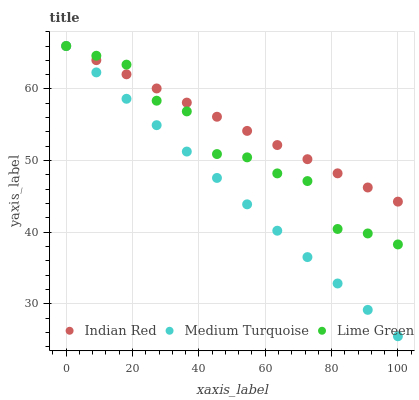Does Medium Turquoise have the minimum area under the curve?
Answer yes or no. Yes. Does Indian Red have the maximum area under the curve?
Answer yes or no. Yes. Does Indian Red have the minimum area under the curve?
Answer yes or no. No. Does Medium Turquoise have the maximum area under the curve?
Answer yes or no. No. Is Indian Red the smoothest?
Answer yes or no. Yes. Is Lime Green the roughest?
Answer yes or no. Yes. Is Medium Turquoise the smoothest?
Answer yes or no. No. Is Medium Turquoise the roughest?
Answer yes or no. No. Does Medium Turquoise have the lowest value?
Answer yes or no. Yes. Does Indian Red have the lowest value?
Answer yes or no. No. Does Indian Red have the highest value?
Answer yes or no. Yes. Does Indian Red intersect Medium Turquoise?
Answer yes or no. Yes. Is Indian Red less than Medium Turquoise?
Answer yes or no. No. Is Indian Red greater than Medium Turquoise?
Answer yes or no. No. 